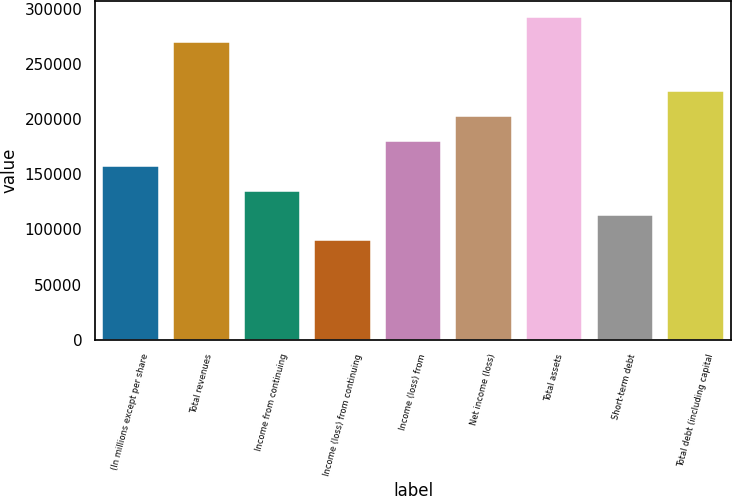Convert chart to OTSL. <chart><loc_0><loc_0><loc_500><loc_500><bar_chart><fcel>(In millions except per share<fcel>Total revenues<fcel>Income from continuing<fcel>Income (loss) from continuing<fcel>Income (loss) from<fcel>Net income (loss)<fcel>Total assets<fcel>Short-term debt<fcel>Total debt (including capital<nl><fcel>157682<fcel>270312<fcel>135156<fcel>90104.4<fcel>180208<fcel>202734<fcel>292838<fcel>112630<fcel>225260<nl></chart> 